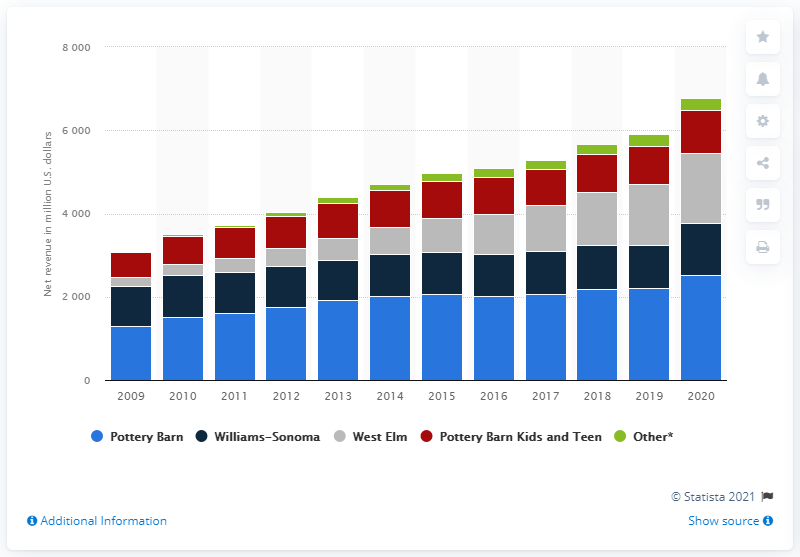Give some essential details in this illustration. In 2020, Pottery Barn's global net revenue was 2526.24. 